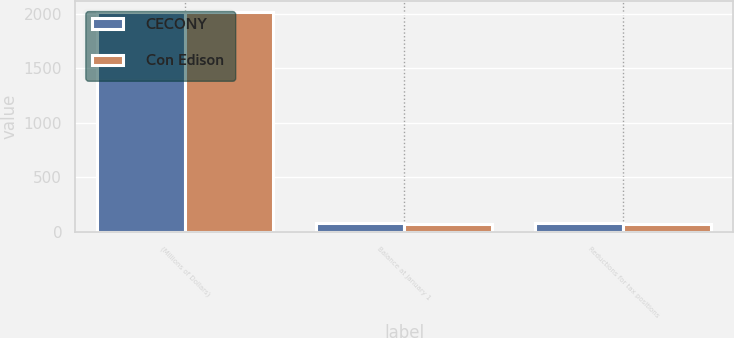Convert chart to OTSL. <chart><loc_0><loc_0><loc_500><loc_500><stacked_bar_chart><ecel><fcel>(Millions of Dollars)<fcel>Balance at January 1<fcel>Reductions for tax positions<nl><fcel>CECONY<fcel>2013<fcel>86<fcel>86<nl><fcel>Con Edison<fcel>2013<fcel>74<fcel>74<nl></chart> 